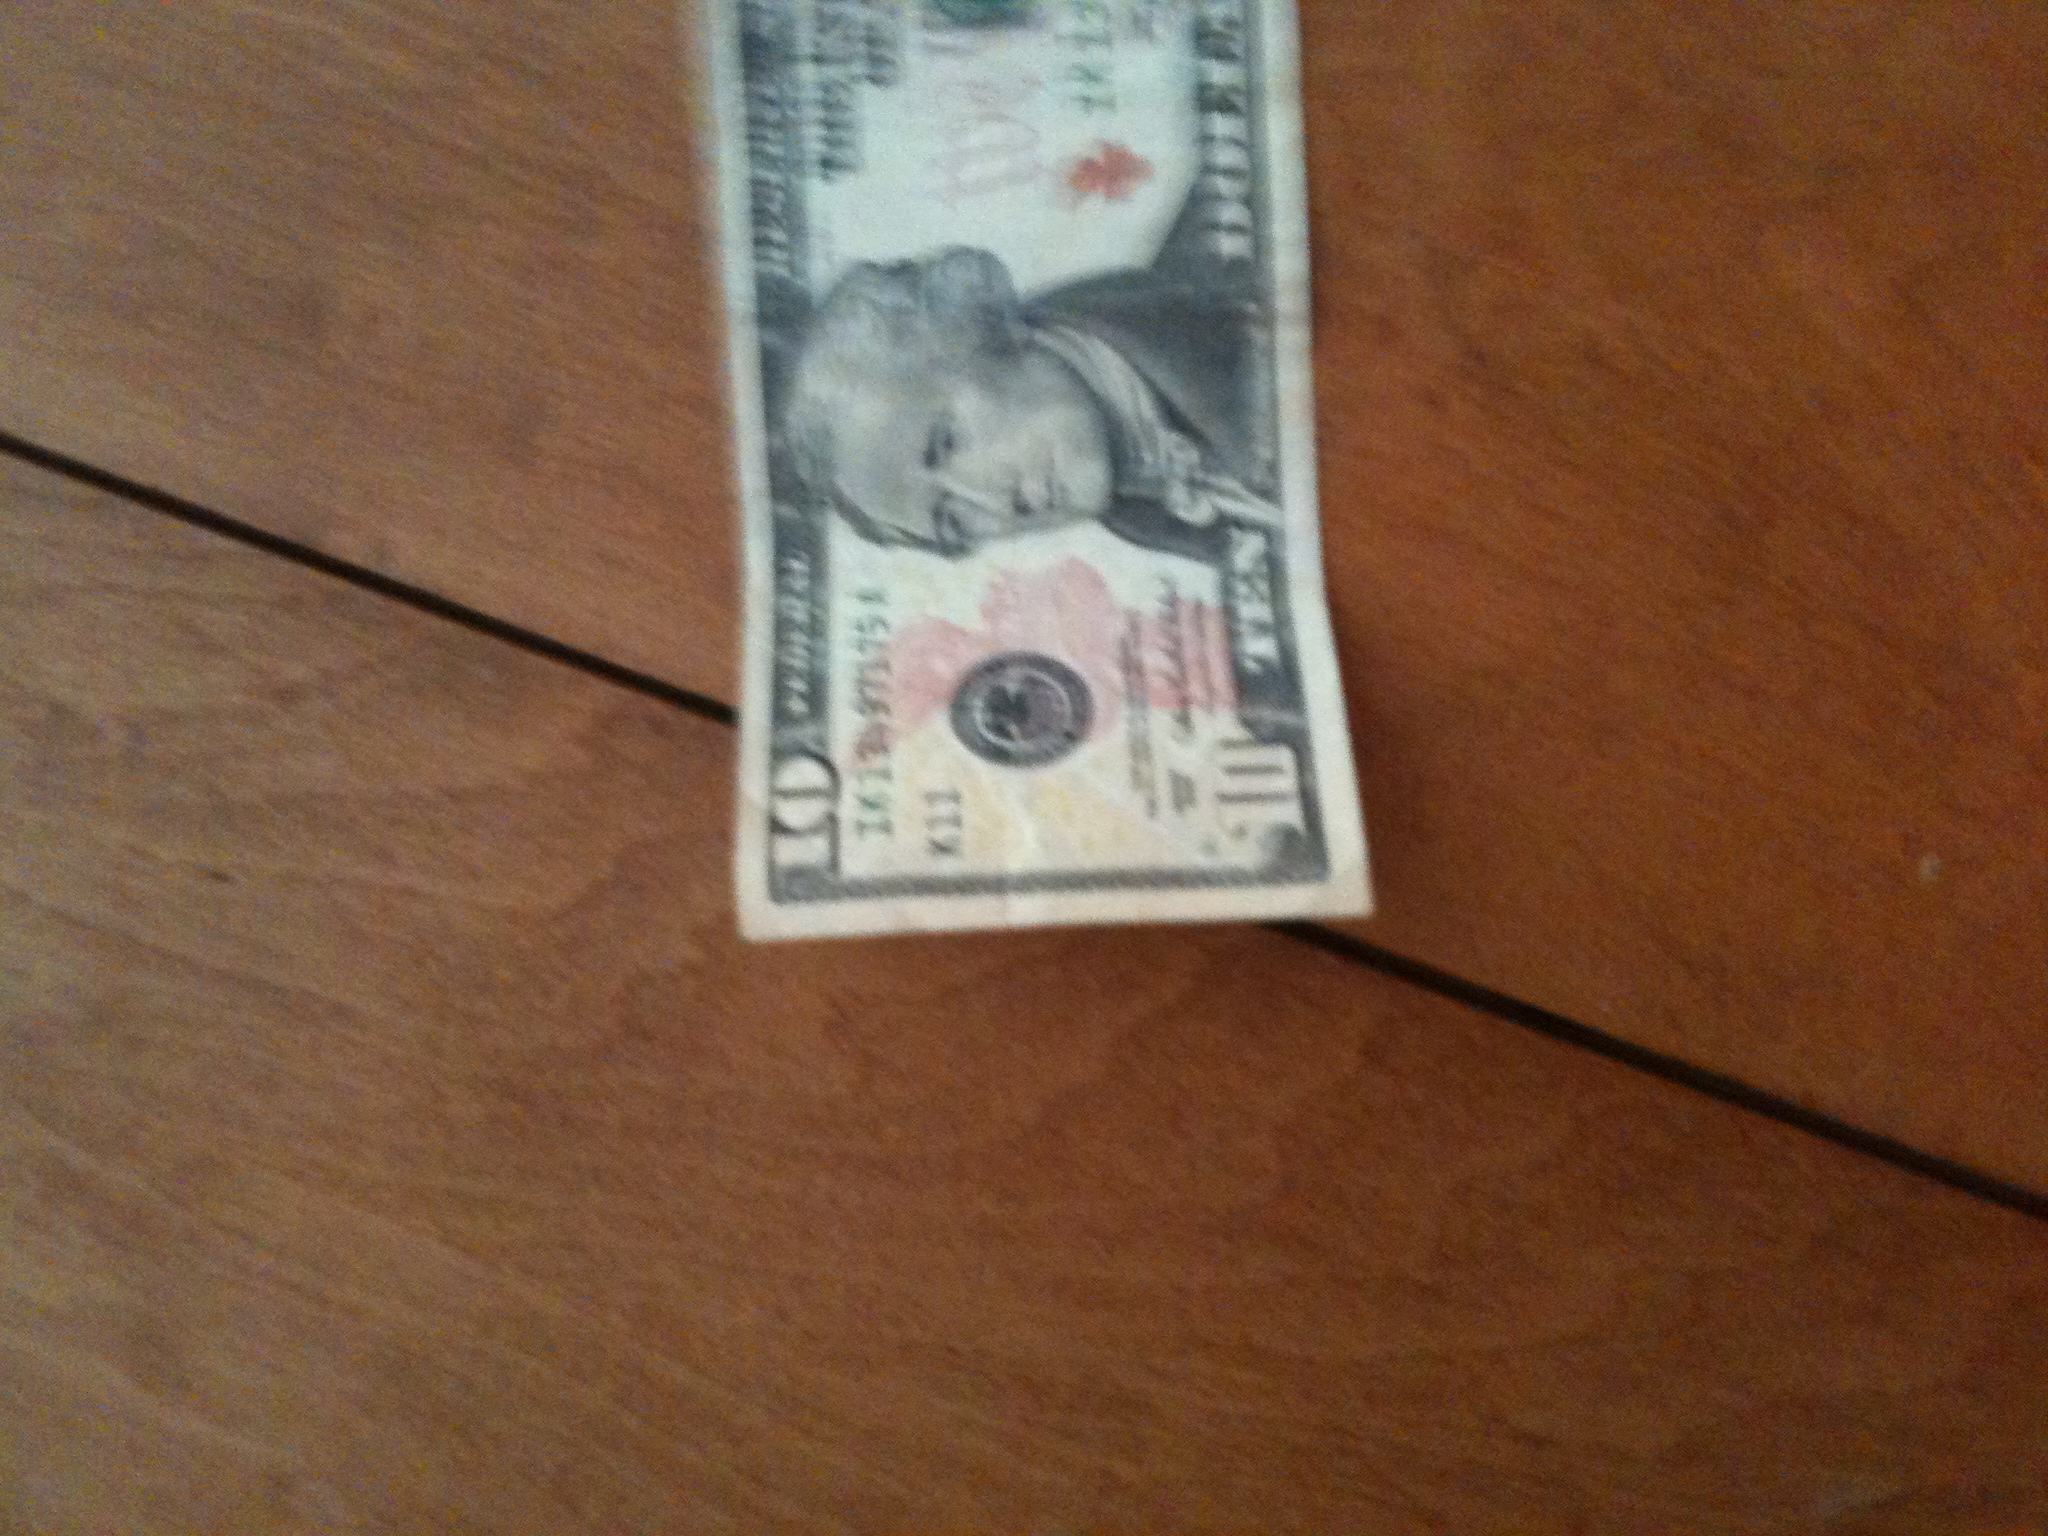Does this bill have any historical significance? Yes, the 10-dollar bill is significant, not only because it is a widely used denomination, but also because it features Alexander Hamilton, who was the first Secretary of the Treasury and a pivotal figure in the founding of the American financial system. What can you tell me about Alexander Hamilton's role in American history? Alexander Hamilton was an influential statesman, one of the Founding Fathers of the United States, and the first Secretary of the Treasury. He played a crucial role in the creation of the United States' financial system, establishing the national bank, shaping economic policy, and promoting federal investment in industry. Hamilton was also a co-author of the Federalist Papers, advocating for the ratification of the U.S. Constitution. Wow, Hamilton sounds like a fascinating figure. Could you imagine a world where he did not exist? How would it be different? If Alexander Hamilton had not existed, the financial and economic landscape of the United States might be drastically different. Without his influence, the establishment of a strong federal financial system could have been delayed or developed differently, potentially hindering the country's early growth and stability. The absence of the Federalist Papers might have also impacted the ratification of the Constitution, leading to a very different political structure in the early United States. In addition, the Treasury Department's policies and the structure of national credit and banking systems might have evolved in ways that are difficult to predict, potentially altering the economic trajectory of the nation. 